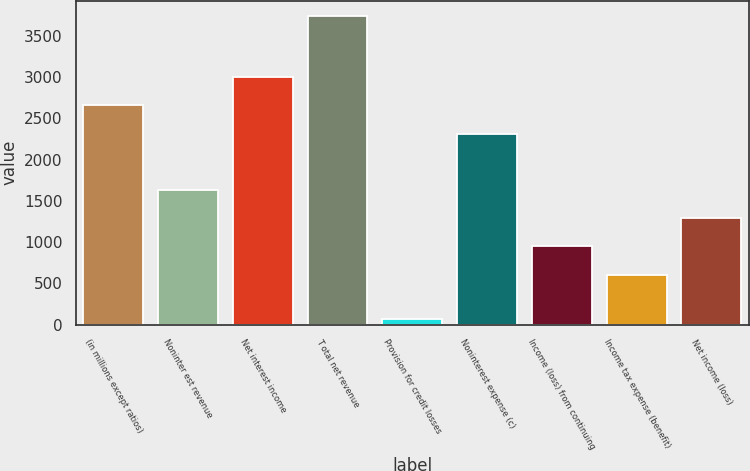Convert chart. <chart><loc_0><loc_0><loc_500><loc_500><bar_chart><fcel>(in millions except ratios)<fcel>Noninter est revenue<fcel>Net interest income<fcel>T otal net revenue<fcel>Provision for credit losses<fcel>Noninterest expense (c)<fcel>Income (loss) from continuing<fcel>Income tax expense (benefit)<fcel>Net income (loss)<nl><fcel>2658.5<fcel>1634<fcel>3000<fcel>3741.5<fcel>73<fcel>2317<fcel>951<fcel>608<fcel>1292.5<nl></chart> 